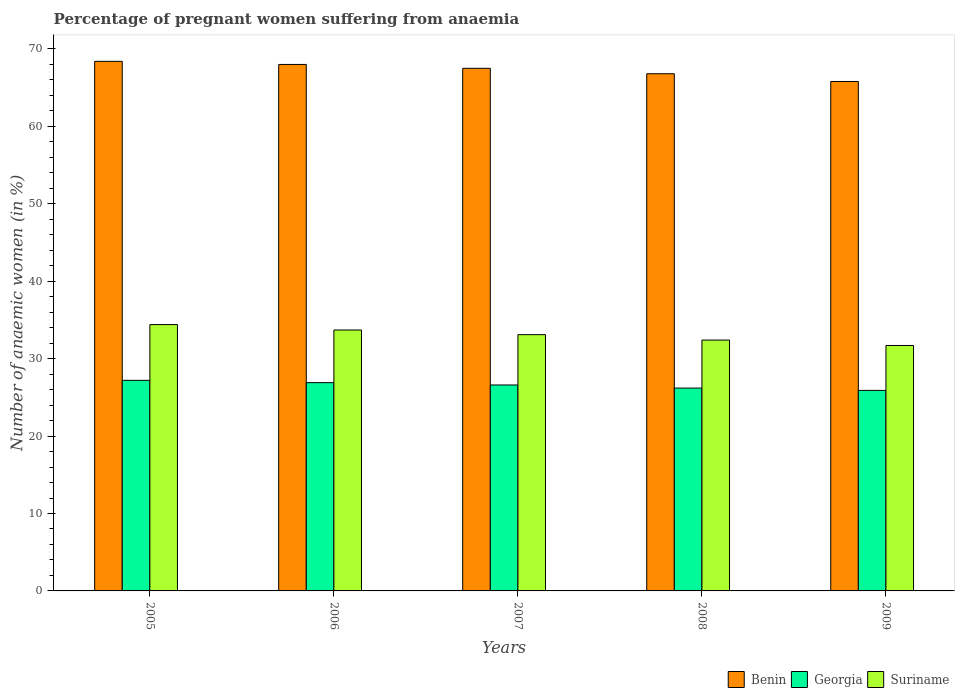Are the number of bars per tick equal to the number of legend labels?
Your response must be concise. Yes. How many bars are there on the 3rd tick from the left?
Ensure brevity in your answer.  3. How many bars are there on the 2nd tick from the right?
Keep it short and to the point. 3. In how many cases, is the number of bars for a given year not equal to the number of legend labels?
Make the answer very short. 0. What is the number of anaemic women in Georgia in 2005?
Keep it short and to the point. 27.2. Across all years, what is the maximum number of anaemic women in Georgia?
Your answer should be very brief. 27.2. Across all years, what is the minimum number of anaemic women in Suriname?
Offer a very short reply. 31.7. In which year was the number of anaemic women in Suriname maximum?
Give a very brief answer. 2005. What is the total number of anaemic women in Benin in the graph?
Provide a succinct answer. 336.5. What is the difference between the number of anaemic women in Suriname in 2006 and that in 2008?
Provide a short and direct response. 1.3. What is the difference between the number of anaemic women in Suriname in 2005 and the number of anaemic women in Benin in 2006?
Your answer should be compact. -33.6. What is the average number of anaemic women in Suriname per year?
Offer a very short reply. 33.06. In the year 2008, what is the difference between the number of anaemic women in Georgia and number of anaemic women in Suriname?
Make the answer very short. -6.2. In how many years, is the number of anaemic women in Georgia greater than 34 %?
Ensure brevity in your answer.  0. What is the ratio of the number of anaemic women in Suriname in 2005 to that in 2009?
Offer a very short reply. 1.09. Is the number of anaemic women in Benin in 2005 less than that in 2007?
Your answer should be compact. No. Is the difference between the number of anaemic women in Georgia in 2006 and 2008 greater than the difference between the number of anaemic women in Suriname in 2006 and 2008?
Make the answer very short. No. What is the difference between the highest and the second highest number of anaemic women in Benin?
Your answer should be very brief. 0.4. What is the difference between the highest and the lowest number of anaemic women in Suriname?
Your response must be concise. 2.7. What does the 1st bar from the left in 2009 represents?
Offer a terse response. Benin. What does the 3rd bar from the right in 2009 represents?
Provide a short and direct response. Benin. Is it the case that in every year, the sum of the number of anaemic women in Suriname and number of anaemic women in Georgia is greater than the number of anaemic women in Benin?
Provide a short and direct response. No. How many bars are there?
Provide a succinct answer. 15. Are the values on the major ticks of Y-axis written in scientific E-notation?
Your answer should be compact. No. Where does the legend appear in the graph?
Keep it short and to the point. Bottom right. How many legend labels are there?
Give a very brief answer. 3. How are the legend labels stacked?
Provide a succinct answer. Horizontal. What is the title of the graph?
Provide a succinct answer. Percentage of pregnant women suffering from anaemia. Does "Austria" appear as one of the legend labels in the graph?
Make the answer very short. No. What is the label or title of the X-axis?
Your response must be concise. Years. What is the label or title of the Y-axis?
Your response must be concise. Number of anaemic women (in %). What is the Number of anaemic women (in %) in Benin in 2005?
Keep it short and to the point. 68.4. What is the Number of anaemic women (in %) in Georgia in 2005?
Offer a terse response. 27.2. What is the Number of anaemic women (in %) in Suriname in 2005?
Make the answer very short. 34.4. What is the Number of anaemic women (in %) in Benin in 2006?
Your answer should be compact. 68. What is the Number of anaemic women (in %) in Georgia in 2006?
Your answer should be compact. 26.9. What is the Number of anaemic women (in %) in Suriname in 2006?
Offer a very short reply. 33.7. What is the Number of anaemic women (in %) in Benin in 2007?
Keep it short and to the point. 67.5. What is the Number of anaemic women (in %) in Georgia in 2007?
Ensure brevity in your answer.  26.6. What is the Number of anaemic women (in %) of Suriname in 2007?
Your answer should be compact. 33.1. What is the Number of anaemic women (in %) of Benin in 2008?
Make the answer very short. 66.8. What is the Number of anaemic women (in %) in Georgia in 2008?
Offer a very short reply. 26.2. What is the Number of anaemic women (in %) in Suriname in 2008?
Your response must be concise. 32.4. What is the Number of anaemic women (in %) in Benin in 2009?
Offer a terse response. 65.8. What is the Number of anaemic women (in %) of Georgia in 2009?
Make the answer very short. 25.9. What is the Number of anaemic women (in %) in Suriname in 2009?
Offer a terse response. 31.7. Across all years, what is the maximum Number of anaemic women (in %) in Benin?
Your answer should be very brief. 68.4. Across all years, what is the maximum Number of anaemic women (in %) of Georgia?
Offer a terse response. 27.2. Across all years, what is the maximum Number of anaemic women (in %) in Suriname?
Provide a short and direct response. 34.4. Across all years, what is the minimum Number of anaemic women (in %) in Benin?
Offer a very short reply. 65.8. Across all years, what is the minimum Number of anaemic women (in %) of Georgia?
Make the answer very short. 25.9. Across all years, what is the minimum Number of anaemic women (in %) of Suriname?
Ensure brevity in your answer.  31.7. What is the total Number of anaemic women (in %) in Benin in the graph?
Make the answer very short. 336.5. What is the total Number of anaemic women (in %) of Georgia in the graph?
Offer a very short reply. 132.8. What is the total Number of anaemic women (in %) in Suriname in the graph?
Your answer should be very brief. 165.3. What is the difference between the Number of anaemic women (in %) in Benin in 2005 and that in 2006?
Provide a short and direct response. 0.4. What is the difference between the Number of anaemic women (in %) in Georgia in 2005 and that in 2006?
Provide a succinct answer. 0.3. What is the difference between the Number of anaemic women (in %) of Suriname in 2005 and that in 2006?
Your response must be concise. 0.7. What is the difference between the Number of anaemic women (in %) of Benin in 2005 and that in 2007?
Your response must be concise. 0.9. What is the difference between the Number of anaemic women (in %) in Georgia in 2005 and that in 2007?
Offer a very short reply. 0.6. What is the difference between the Number of anaemic women (in %) of Benin in 2005 and that in 2008?
Keep it short and to the point. 1.6. What is the difference between the Number of anaemic women (in %) of Georgia in 2005 and that in 2008?
Offer a very short reply. 1. What is the difference between the Number of anaemic women (in %) in Georgia in 2005 and that in 2009?
Provide a short and direct response. 1.3. What is the difference between the Number of anaemic women (in %) in Suriname in 2005 and that in 2009?
Offer a very short reply. 2.7. What is the difference between the Number of anaemic women (in %) of Georgia in 2006 and that in 2007?
Provide a short and direct response. 0.3. What is the difference between the Number of anaemic women (in %) in Suriname in 2006 and that in 2007?
Keep it short and to the point. 0.6. What is the difference between the Number of anaemic women (in %) in Georgia in 2006 and that in 2008?
Offer a very short reply. 0.7. What is the difference between the Number of anaemic women (in %) in Georgia in 2006 and that in 2009?
Give a very brief answer. 1. What is the difference between the Number of anaemic women (in %) in Suriname in 2006 and that in 2009?
Your answer should be very brief. 2. What is the difference between the Number of anaemic women (in %) of Benin in 2007 and that in 2008?
Your response must be concise. 0.7. What is the difference between the Number of anaemic women (in %) in Benin in 2007 and that in 2009?
Your answer should be compact. 1.7. What is the difference between the Number of anaemic women (in %) of Georgia in 2007 and that in 2009?
Give a very brief answer. 0.7. What is the difference between the Number of anaemic women (in %) in Suriname in 2007 and that in 2009?
Make the answer very short. 1.4. What is the difference between the Number of anaemic women (in %) of Georgia in 2008 and that in 2009?
Give a very brief answer. 0.3. What is the difference between the Number of anaemic women (in %) in Suriname in 2008 and that in 2009?
Give a very brief answer. 0.7. What is the difference between the Number of anaemic women (in %) of Benin in 2005 and the Number of anaemic women (in %) of Georgia in 2006?
Offer a terse response. 41.5. What is the difference between the Number of anaemic women (in %) in Benin in 2005 and the Number of anaemic women (in %) in Suriname in 2006?
Provide a short and direct response. 34.7. What is the difference between the Number of anaemic women (in %) in Georgia in 2005 and the Number of anaemic women (in %) in Suriname in 2006?
Your response must be concise. -6.5. What is the difference between the Number of anaemic women (in %) in Benin in 2005 and the Number of anaemic women (in %) in Georgia in 2007?
Provide a short and direct response. 41.8. What is the difference between the Number of anaemic women (in %) of Benin in 2005 and the Number of anaemic women (in %) of Suriname in 2007?
Keep it short and to the point. 35.3. What is the difference between the Number of anaemic women (in %) in Benin in 2005 and the Number of anaemic women (in %) in Georgia in 2008?
Give a very brief answer. 42.2. What is the difference between the Number of anaemic women (in %) of Benin in 2005 and the Number of anaemic women (in %) of Suriname in 2008?
Offer a very short reply. 36. What is the difference between the Number of anaemic women (in %) in Georgia in 2005 and the Number of anaemic women (in %) in Suriname in 2008?
Give a very brief answer. -5.2. What is the difference between the Number of anaemic women (in %) in Benin in 2005 and the Number of anaemic women (in %) in Georgia in 2009?
Provide a short and direct response. 42.5. What is the difference between the Number of anaemic women (in %) in Benin in 2005 and the Number of anaemic women (in %) in Suriname in 2009?
Give a very brief answer. 36.7. What is the difference between the Number of anaemic women (in %) of Georgia in 2005 and the Number of anaemic women (in %) of Suriname in 2009?
Give a very brief answer. -4.5. What is the difference between the Number of anaemic women (in %) in Benin in 2006 and the Number of anaemic women (in %) in Georgia in 2007?
Provide a short and direct response. 41.4. What is the difference between the Number of anaemic women (in %) in Benin in 2006 and the Number of anaemic women (in %) in Suriname in 2007?
Keep it short and to the point. 34.9. What is the difference between the Number of anaemic women (in %) in Georgia in 2006 and the Number of anaemic women (in %) in Suriname in 2007?
Keep it short and to the point. -6.2. What is the difference between the Number of anaemic women (in %) of Benin in 2006 and the Number of anaemic women (in %) of Georgia in 2008?
Give a very brief answer. 41.8. What is the difference between the Number of anaemic women (in %) in Benin in 2006 and the Number of anaemic women (in %) in Suriname in 2008?
Offer a terse response. 35.6. What is the difference between the Number of anaemic women (in %) of Benin in 2006 and the Number of anaemic women (in %) of Georgia in 2009?
Keep it short and to the point. 42.1. What is the difference between the Number of anaemic women (in %) in Benin in 2006 and the Number of anaemic women (in %) in Suriname in 2009?
Your answer should be very brief. 36.3. What is the difference between the Number of anaemic women (in %) of Benin in 2007 and the Number of anaemic women (in %) of Georgia in 2008?
Make the answer very short. 41.3. What is the difference between the Number of anaemic women (in %) of Benin in 2007 and the Number of anaemic women (in %) of Suriname in 2008?
Offer a very short reply. 35.1. What is the difference between the Number of anaemic women (in %) of Benin in 2007 and the Number of anaemic women (in %) of Georgia in 2009?
Offer a very short reply. 41.6. What is the difference between the Number of anaemic women (in %) in Benin in 2007 and the Number of anaemic women (in %) in Suriname in 2009?
Provide a succinct answer. 35.8. What is the difference between the Number of anaemic women (in %) in Benin in 2008 and the Number of anaemic women (in %) in Georgia in 2009?
Provide a short and direct response. 40.9. What is the difference between the Number of anaemic women (in %) in Benin in 2008 and the Number of anaemic women (in %) in Suriname in 2009?
Provide a short and direct response. 35.1. What is the average Number of anaemic women (in %) in Benin per year?
Make the answer very short. 67.3. What is the average Number of anaemic women (in %) in Georgia per year?
Make the answer very short. 26.56. What is the average Number of anaemic women (in %) of Suriname per year?
Keep it short and to the point. 33.06. In the year 2005, what is the difference between the Number of anaemic women (in %) of Benin and Number of anaemic women (in %) of Georgia?
Ensure brevity in your answer.  41.2. In the year 2005, what is the difference between the Number of anaemic women (in %) of Georgia and Number of anaemic women (in %) of Suriname?
Your answer should be very brief. -7.2. In the year 2006, what is the difference between the Number of anaemic women (in %) of Benin and Number of anaemic women (in %) of Georgia?
Provide a short and direct response. 41.1. In the year 2006, what is the difference between the Number of anaemic women (in %) in Benin and Number of anaemic women (in %) in Suriname?
Keep it short and to the point. 34.3. In the year 2006, what is the difference between the Number of anaemic women (in %) in Georgia and Number of anaemic women (in %) in Suriname?
Offer a very short reply. -6.8. In the year 2007, what is the difference between the Number of anaemic women (in %) of Benin and Number of anaemic women (in %) of Georgia?
Offer a terse response. 40.9. In the year 2007, what is the difference between the Number of anaemic women (in %) of Benin and Number of anaemic women (in %) of Suriname?
Ensure brevity in your answer.  34.4. In the year 2008, what is the difference between the Number of anaemic women (in %) in Benin and Number of anaemic women (in %) in Georgia?
Provide a short and direct response. 40.6. In the year 2008, what is the difference between the Number of anaemic women (in %) in Benin and Number of anaemic women (in %) in Suriname?
Provide a short and direct response. 34.4. In the year 2008, what is the difference between the Number of anaemic women (in %) in Georgia and Number of anaemic women (in %) in Suriname?
Your answer should be very brief. -6.2. In the year 2009, what is the difference between the Number of anaemic women (in %) of Benin and Number of anaemic women (in %) of Georgia?
Offer a very short reply. 39.9. In the year 2009, what is the difference between the Number of anaemic women (in %) of Benin and Number of anaemic women (in %) of Suriname?
Provide a succinct answer. 34.1. In the year 2009, what is the difference between the Number of anaemic women (in %) of Georgia and Number of anaemic women (in %) of Suriname?
Provide a short and direct response. -5.8. What is the ratio of the Number of anaemic women (in %) in Benin in 2005 to that in 2006?
Provide a short and direct response. 1.01. What is the ratio of the Number of anaemic women (in %) of Georgia in 2005 to that in 2006?
Offer a very short reply. 1.01. What is the ratio of the Number of anaemic women (in %) of Suriname in 2005 to that in 2006?
Offer a very short reply. 1.02. What is the ratio of the Number of anaemic women (in %) of Benin in 2005 to that in 2007?
Give a very brief answer. 1.01. What is the ratio of the Number of anaemic women (in %) in Georgia in 2005 to that in 2007?
Provide a short and direct response. 1.02. What is the ratio of the Number of anaemic women (in %) in Suriname in 2005 to that in 2007?
Ensure brevity in your answer.  1.04. What is the ratio of the Number of anaemic women (in %) in Georgia in 2005 to that in 2008?
Your response must be concise. 1.04. What is the ratio of the Number of anaemic women (in %) in Suriname in 2005 to that in 2008?
Your answer should be compact. 1.06. What is the ratio of the Number of anaemic women (in %) in Benin in 2005 to that in 2009?
Make the answer very short. 1.04. What is the ratio of the Number of anaemic women (in %) in Georgia in 2005 to that in 2009?
Provide a succinct answer. 1.05. What is the ratio of the Number of anaemic women (in %) in Suriname in 2005 to that in 2009?
Offer a terse response. 1.09. What is the ratio of the Number of anaemic women (in %) of Benin in 2006 to that in 2007?
Your answer should be compact. 1.01. What is the ratio of the Number of anaemic women (in %) in Georgia in 2006 to that in 2007?
Your answer should be compact. 1.01. What is the ratio of the Number of anaemic women (in %) of Suriname in 2006 to that in 2007?
Offer a terse response. 1.02. What is the ratio of the Number of anaemic women (in %) in Benin in 2006 to that in 2008?
Give a very brief answer. 1.02. What is the ratio of the Number of anaemic women (in %) in Georgia in 2006 to that in 2008?
Keep it short and to the point. 1.03. What is the ratio of the Number of anaemic women (in %) of Suriname in 2006 to that in 2008?
Your answer should be compact. 1.04. What is the ratio of the Number of anaemic women (in %) in Benin in 2006 to that in 2009?
Ensure brevity in your answer.  1.03. What is the ratio of the Number of anaemic women (in %) of Georgia in 2006 to that in 2009?
Your answer should be compact. 1.04. What is the ratio of the Number of anaemic women (in %) in Suriname in 2006 to that in 2009?
Keep it short and to the point. 1.06. What is the ratio of the Number of anaemic women (in %) of Benin in 2007 to that in 2008?
Make the answer very short. 1.01. What is the ratio of the Number of anaemic women (in %) of Georgia in 2007 to that in 2008?
Provide a short and direct response. 1.02. What is the ratio of the Number of anaemic women (in %) of Suriname in 2007 to that in 2008?
Your answer should be very brief. 1.02. What is the ratio of the Number of anaemic women (in %) of Benin in 2007 to that in 2009?
Your answer should be very brief. 1.03. What is the ratio of the Number of anaemic women (in %) in Suriname in 2007 to that in 2009?
Your response must be concise. 1.04. What is the ratio of the Number of anaemic women (in %) in Benin in 2008 to that in 2009?
Keep it short and to the point. 1.02. What is the ratio of the Number of anaemic women (in %) in Georgia in 2008 to that in 2009?
Give a very brief answer. 1.01. What is the ratio of the Number of anaemic women (in %) of Suriname in 2008 to that in 2009?
Your answer should be very brief. 1.02. What is the difference between the highest and the second highest Number of anaemic women (in %) of Georgia?
Offer a terse response. 0.3. What is the difference between the highest and the second highest Number of anaemic women (in %) of Suriname?
Your answer should be very brief. 0.7. What is the difference between the highest and the lowest Number of anaemic women (in %) in Benin?
Keep it short and to the point. 2.6. What is the difference between the highest and the lowest Number of anaemic women (in %) of Georgia?
Ensure brevity in your answer.  1.3. What is the difference between the highest and the lowest Number of anaemic women (in %) in Suriname?
Make the answer very short. 2.7. 